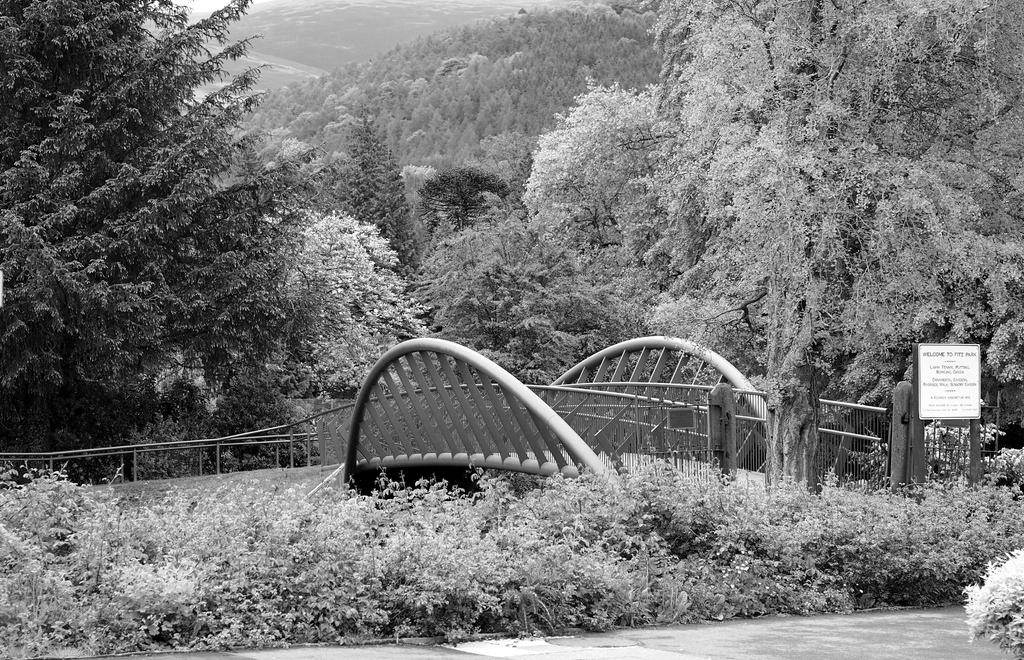What type of structure can be seen in the image? There is a bridge in the image. What type of natural elements are present in the image? There are plants and trees in the image. Where is the sign board located in the image? The sign board is on the right side of the image. What type of payment is accepted by the actor in the image? There is no actor present in the image, and therefore no payment can be accepted. 